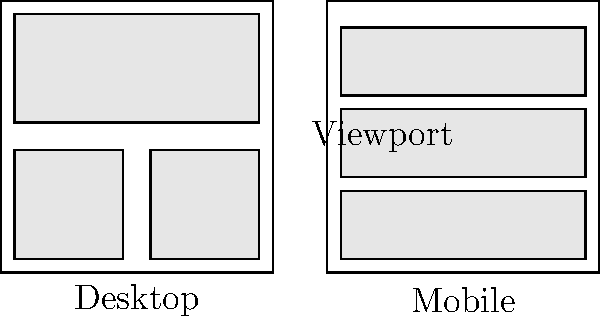In designing a responsive layout for manga panels on a website, which CSS property is most crucial for adjusting the layout from a side-by-side arrangement on desktop to a stacked arrangement on mobile devices, as shown in the diagram? To create a responsive layout for manga panels that adjusts from a side-by-side arrangement on desktop to a stacked arrangement on mobile devices, we need to consider the following steps:

1. Understand the layout requirements:
   - Desktop: Panels are arranged horizontally
   - Mobile: Panels are stacked vertically

2. Identify the key CSS property for layout changes:
   The most crucial CSS property for this transformation is `flex-direction`.

3. Implement a flexbox container:
   - Set the parent container to `display: flex;`
   - Use `flex-direction: row;` for the desktop layout
   - Use `flex-direction: column;` for the mobile layout

4. Utilize media queries:
   ```css
   @media (max-width: 768px) {
     .manga-container {
       flex-direction: column;
     }
   }
   ```

5. Additional considerations:
   - Use `flex-wrap: wrap;` for better control over panel wrapping
   - Adjust `width` and `height` of panels as needed
   - Implement `gap` or margins for spacing between panels

The `flex-direction` property is the most crucial because it directly controls the main axis of the flex container, allowing for an easy switch between horizontal and vertical layouts without changing the HTML structure.
Answer: flex-direction 